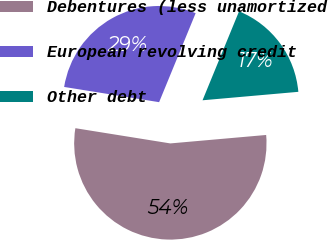<chart> <loc_0><loc_0><loc_500><loc_500><pie_chart><fcel>Debentures (less unamortized<fcel>European revolving credit<fcel>Other debt<nl><fcel>53.93%<fcel>28.67%<fcel>17.4%<nl></chart> 